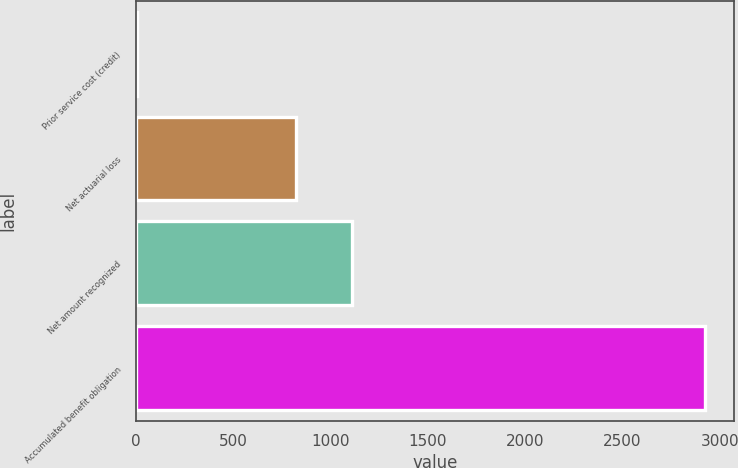Convert chart to OTSL. <chart><loc_0><loc_0><loc_500><loc_500><bar_chart><fcel>Prior service cost (credit)<fcel>Net actuarial loss<fcel>Net amount recognized<fcel>Accumulated benefit obligation<nl><fcel>3<fcel>819<fcel>1111.2<fcel>2925<nl></chart> 